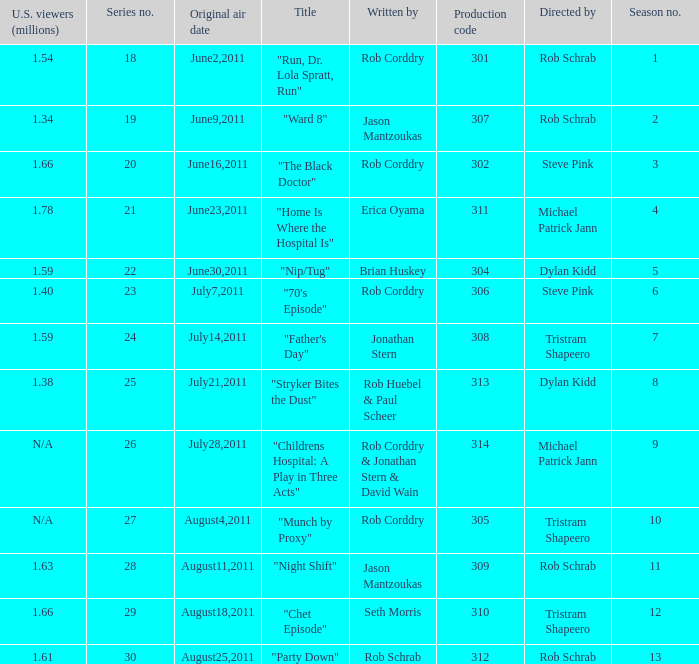The episode entitled "ward 8" was what number in the series? 19.0. 